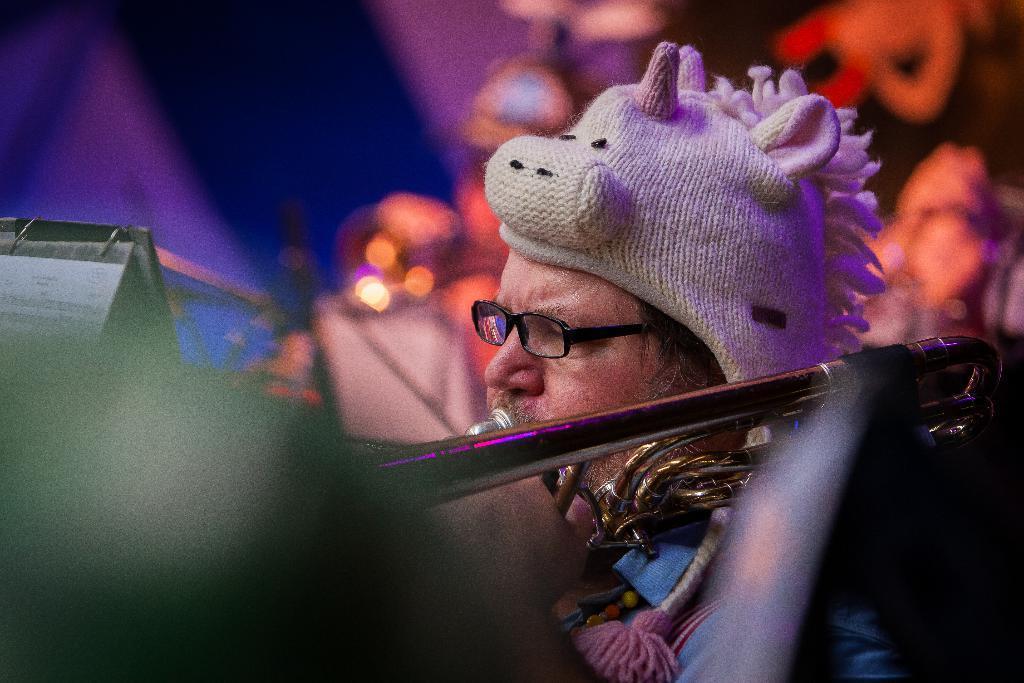In one or two sentences, can you explain what this image depicts? In this picture we can see a man wore spectacle, cap and playing saxophone holding in his hand and in front of him there is stand and in background it is blur. 